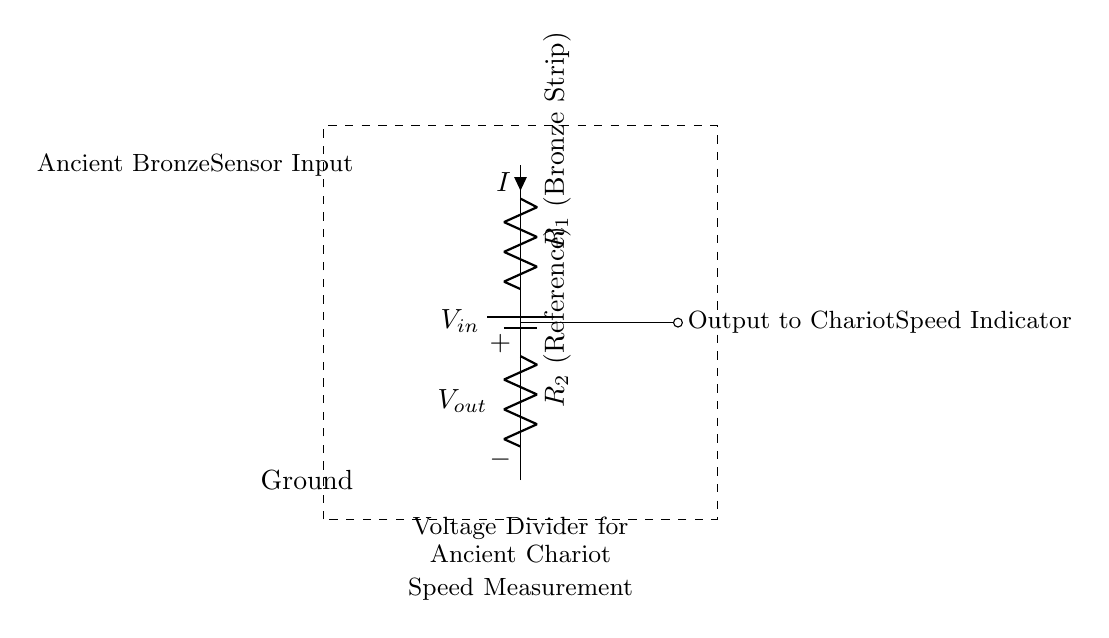What is the purpose of this circuit? The circuit functions as a voltage divider, which helps simulate the electrical output of ancient bronze sensors to measure the speed of chariots.
Answer: Voltage divider for speed measurement What components are present in the circuit? The circuit includes a battery, two resistors (R1 and R2), and output to a speed indicator.
Answer: Battery, R1, R2 What does Vout represent in this circuit? Vout is the output voltage from the voltage divider, which is fed to the speed indicator to indicate the chariot's speed.
Answer: Output voltage What is the role of R1 in the circuit? R1 represents the bronze strip, which is part of the measuring device that interacts with the sensor input.
Answer: Bronze strip How is the output voltage calculated in this voltage divider? The output voltage is calculated using the formula Vout = Vin * (R2 / (R1 + R2)), while taking voltage division into account.
Answer: Vout = Vin * (R2 / (R1 + R2)) What is the significance of the dashed rectangle in the diagram? The dashed rectangle indicates the specific area of focus for the voltage divider circuit and suggests an enclosed structure for the components involved in the measurement.
Answer: Focus area for components What does the current symbol (i) represent in the circuit? The current symbol (i) indicates the flow of electric current through R1, which is a crucial parameter for understanding how the voltage is divided in the circuit.
Answer: Electric current flow 